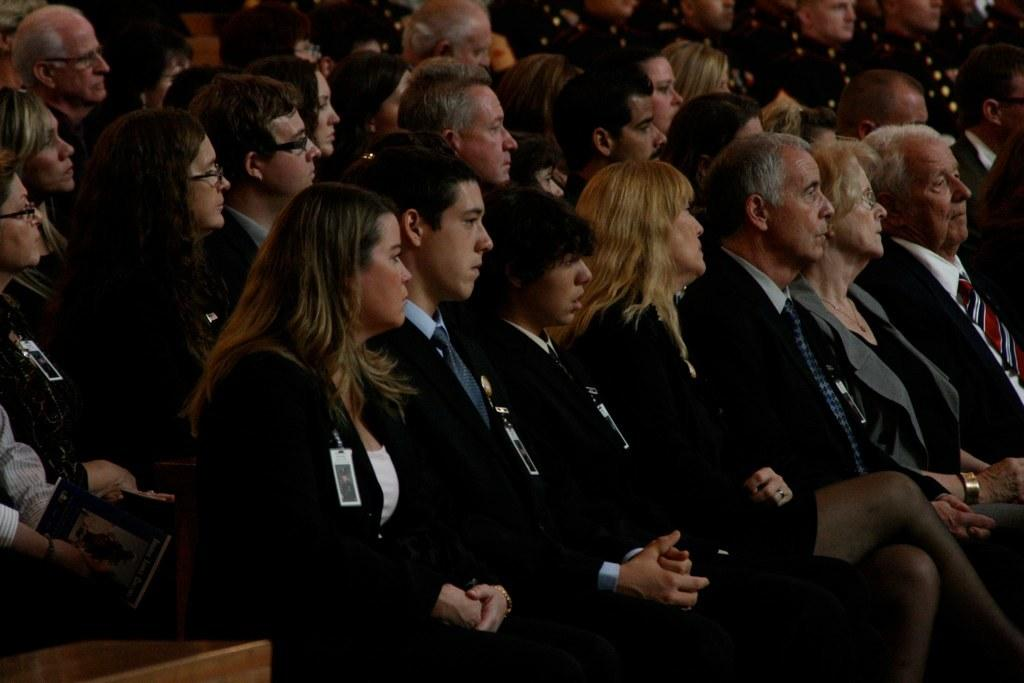What are the people in the image doing? The people in the image are sitting. Can you describe any additional details about the people? Yes, the people are wearing tags. What type of grass is growing on the father's head in the image? There is no father or grass present in the image; it only shows people sitting and wearing tags. 